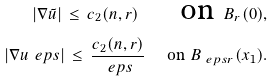Convert formula to latex. <formula><loc_0><loc_0><loc_500><loc_500>| \nabla \tilde { u } | \, \leq \, c _ { 2 } ( n , r ) \quad \text { on } B _ { r } ( 0 ) , \\ | \nabla u _ { \ } e p s | \, \leq \, \frac { c _ { 2 } ( n , r ) } { \ e p s } \quad \text { on } B _ { \ e p s r } ( x _ { 1 } ) .</formula> 